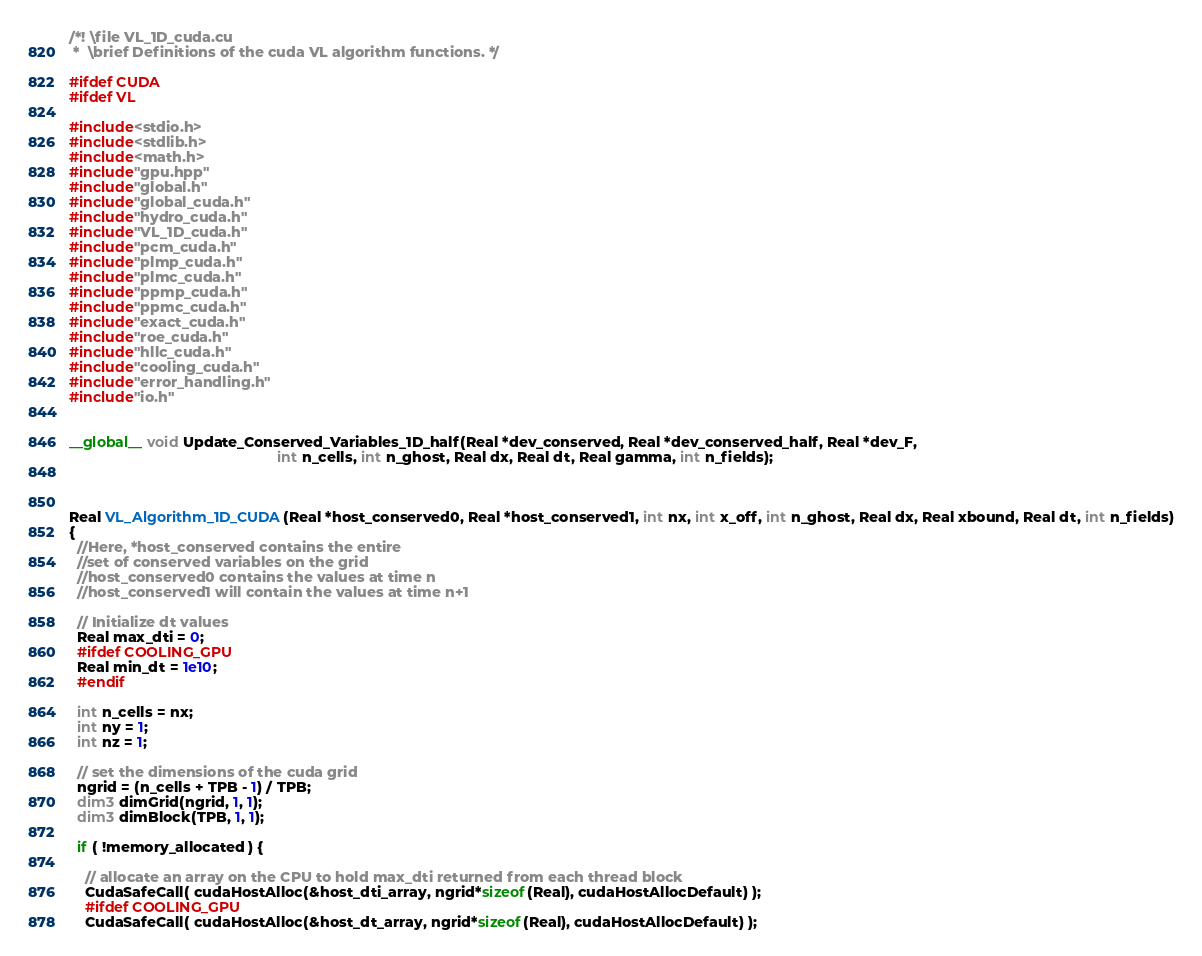<code> <loc_0><loc_0><loc_500><loc_500><_Cuda_>/*! \file VL_1D_cuda.cu
 *  \brief Definitions of the cuda VL algorithm functions. */

#ifdef CUDA
#ifdef VL

#include<stdio.h>
#include<stdlib.h>
#include<math.h>
#include"gpu.hpp"
#include"global.h"
#include"global_cuda.h"
#include"hydro_cuda.h"
#include"VL_1D_cuda.h"
#include"pcm_cuda.h"
#include"plmp_cuda.h"
#include"plmc_cuda.h"
#include"ppmp_cuda.h"
#include"ppmc_cuda.h"
#include"exact_cuda.h"
#include"roe_cuda.h"
#include"hllc_cuda.h"
#include"cooling_cuda.h"
#include"error_handling.h"
#include"io.h"


__global__ void Update_Conserved_Variables_1D_half(Real *dev_conserved, Real *dev_conserved_half, Real *dev_F, 
                                                   int n_cells, int n_ghost, Real dx, Real dt, Real gamma, int n_fields);



Real VL_Algorithm_1D_CUDA(Real *host_conserved0, Real *host_conserved1, int nx, int x_off, int n_ghost, Real dx, Real xbound, Real dt, int n_fields)
{
  //Here, *host_conserved contains the entire
  //set of conserved variables on the grid
  //host_conserved0 contains the values at time n
  //host_conserved1 will contain the values at time n+1

  // Initialize dt values
  Real max_dti = 0;
  #ifdef COOLING_GPU
  Real min_dt = 1e10;
  #endif  

  int n_cells = nx;
  int ny = 1;
  int nz = 1;

  // set the dimensions of the cuda grid
  ngrid = (n_cells + TPB - 1) / TPB;
  dim3 dimGrid(ngrid, 1, 1);
  dim3 dimBlock(TPB, 1, 1);

  if ( !memory_allocated ) {

    // allocate an array on the CPU to hold max_dti returned from each thread block
    CudaSafeCall( cudaHostAlloc(&host_dti_array, ngrid*sizeof(Real), cudaHostAllocDefault) );
    #ifdef COOLING_GPU
    CudaSafeCall( cudaHostAlloc(&host_dt_array, ngrid*sizeof(Real), cudaHostAllocDefault) );</code> 